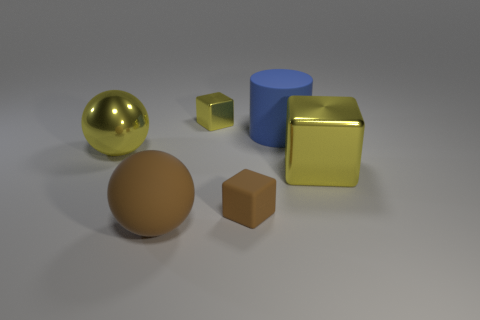How many things are big objects in front of the big blue rubber object or brown objects to the right of the brown rubber sphere?
Provide a succinct answer. 4. Does the big ball that is on the right side of the yellow ball have the same material as the small object in front of the large blue object?
Your answer should be very brief. Yes. There is a matte object left of the yellow metal cube on the left side of the small rubber thing; what is its shape?
Your response must be concise. Sphere. Is there any other thing of the same color as the large shiny sphere?
Your answer should be very brief. Yes. Is there a tiny matte cube on the left side of the big metallic thing to the right of the small thing that is right of the small shiny cube?
Ensure brevity in your answer.  Yes. There is a large metal ball on the left side of the large shiny cube; is it the same color as the big shiny object that is right of the large brown rubber sphere?
Your answer should be compact. Yes. There is a block that is the same size as the blue cylinder; what is it made of?
Ensure brevity in your answer.  Metal. There is a yellow metallic object in front of the yellow metallic thing left of the large brown rubber ball that is in front of the large blue matte thing; how big is it?
Provide a short and direct response. Large. What number of other things are the same material as the brown block?
Offer a terse response. 2. What is the size of the metallic thing right of the blue rubber object?
Offer a very short reply. Large. 